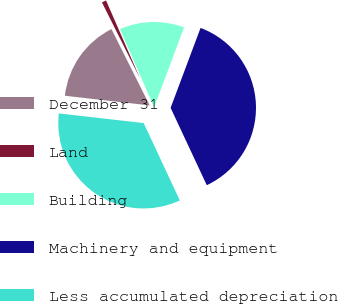Convert chart to OTSL. <chart><loc_0><loc_0><loc_500><loc_500><pie_chart><fcel>December 31<fcel>Land<fcel>Building<fcel>Machinery and equipment<fcel>Less accumulated depreciation<nl><fcel>15.8%<fcel>0.85%<fcel>12.25%<fcel>37.33%<fcel>33.77%<nl></chart> 